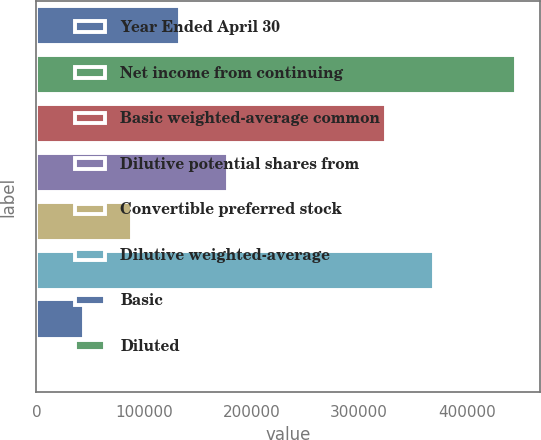<chart> <loc_0><loc_0><loc_500><loc_500><bar_chart><fcel>Year Ended April 30<fcel>Net income from continuing<fcel>Basic weighted-average common<fcel>Dilutive potential shares from<fcel>Convertible preferred stock<fcel>Dilutive weighted-average<fcel>Basic<fcel>Diluted<nl><fcel>133785<fcel>445947<fcel>324810<fcel>178380<fcel>89190.5<fcel>369405<fcel>44595.9<fcel>1.36<nl></chart> 